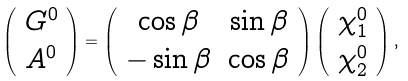<formula> <loc_0><loc_0><loc_500><loc_500>\left ( \begin{array} { c } G ^ { 0 } \\ A ^ { 0 } \\ \end{array} \right ) = \left ( \begin{array} { c c } \cos \beta & \sin \beta \\ - \sin \beta & \cos \beta \\ \end{array} \right ) \left ( \begin{array} { c } \chi _ { 1 } ^ { 0 } \\ \chi _ { 2 } ^ { 0 } \\ \end{array} \right ) ,</formula> 